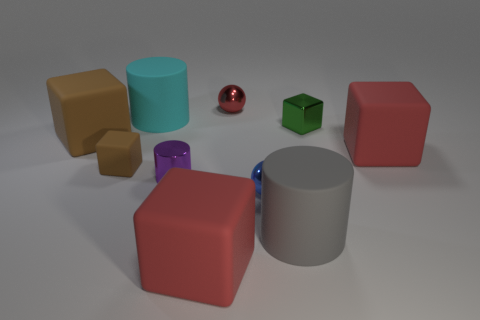Does the green cube to the right of the cyan object have the same size as the blue metal object?
Provide a succinct answer. Yes. There is a matte thing that is in front of the matte cylinder on the right side of the red metal thing; is there a large red block that is on the right side of it?
Ensure brevity in your answer.  Yes. What number of rubber things are gray spheres or tiny blue balls?
Provide a succinct answer. 0. How many other things are there of the same shape as the tiny red object?
Give a very brief answer. 1. Are there more tiny yellow matte cylinders than cyan rubber objects?
Your answer should be very brief. No. There is a red rubber thing that is behind the red cube that is left of the tiny metal sphere that is in front of the small green block; how big is it?
Your answer should be compact. Large. How big is the cube that is in front of the large gray matte object?
Your response must be concise. Large. How many objects are either large yellow spheres or tiny shiny spheres that are in front of the red sphere?
Offer a very short reply. 1. There is another tiny thing that is the same shape as the cyan matte object; what material is it?
Offer a terse response. Metal. Are there more rubber objects right of the small blue metallic thing than red shiny spheres?
Make the answer very short. Yes. 